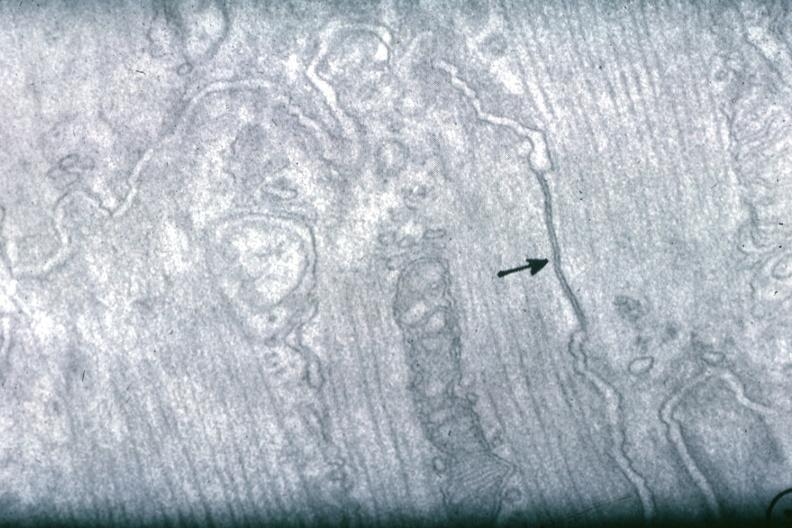what is present?
Answer the question using a single word or phrase. Cardiovascular 